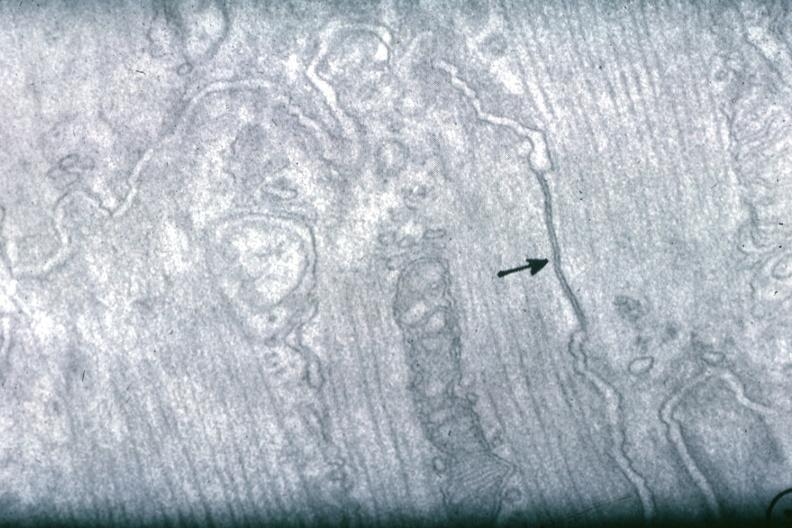what is present?
Answer the question using a single word or phrase. Cardiovascular 